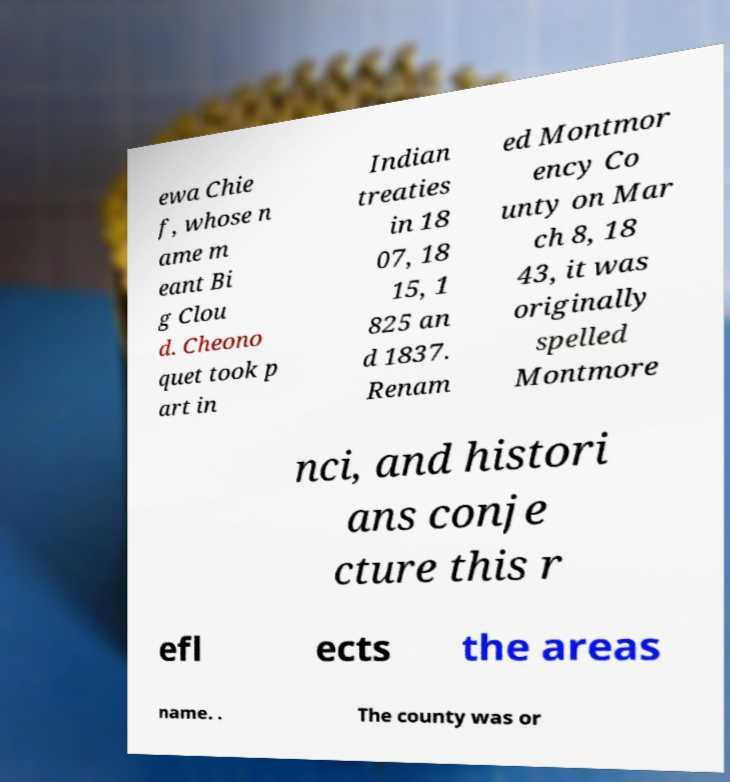I need the written content from this picture converted into text. Can you do that? ewa Chie f, whose n ame m eant Bi g Clou d. Cheono quet took p art in Indian treaties in 18 07, 18 15, 1 825 an d 1837. Renam ed Montmor ency Co unty on Mar ch 8, 18 43, it was originally spelled Montmore nci, and histori ans conje cture this r efl ects the areas name. . The county was or 